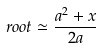<formula> <loc_0><loc_0><loc_500><loc_500>r o o t \simeq \frac { a ^ { 2 } + x } { 2 a }</formula> 